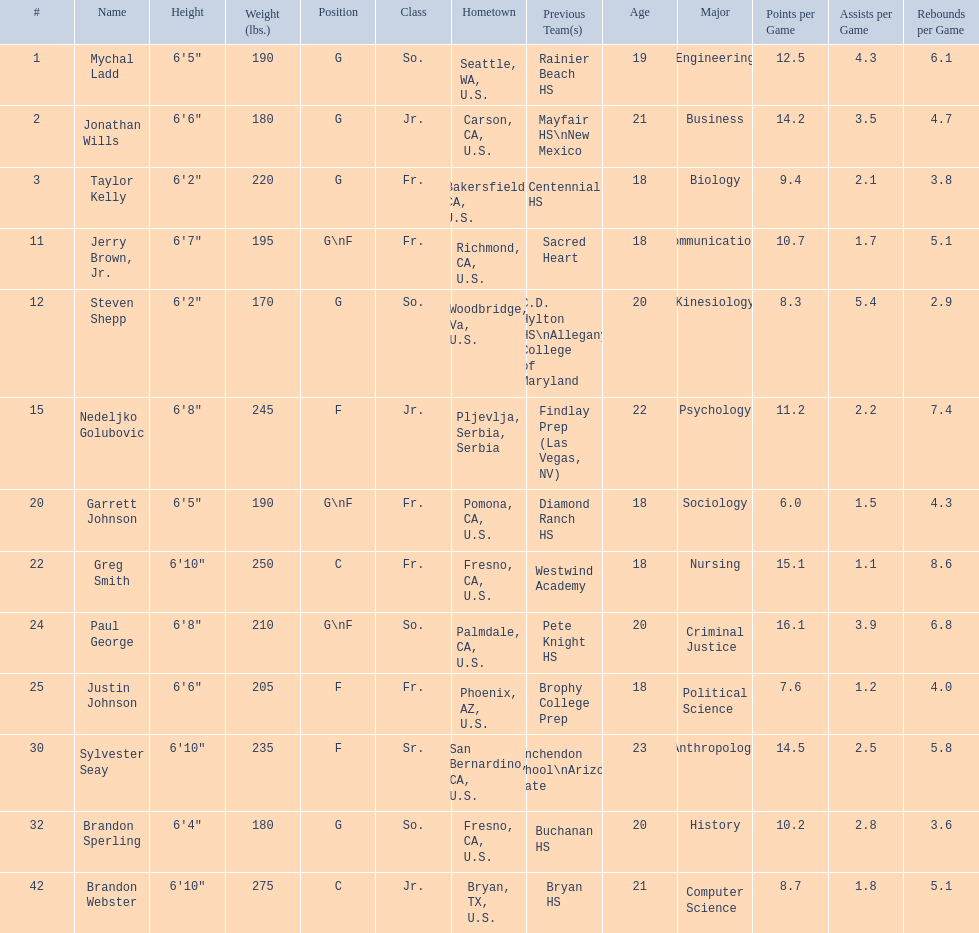Where were all of the players born? So., Jr., Fr., Fr., So., Jr., Fr., Fr., So., Fr., Sr., So., Jr. Who is the one from serbia? Nedeljko Golubovic. 